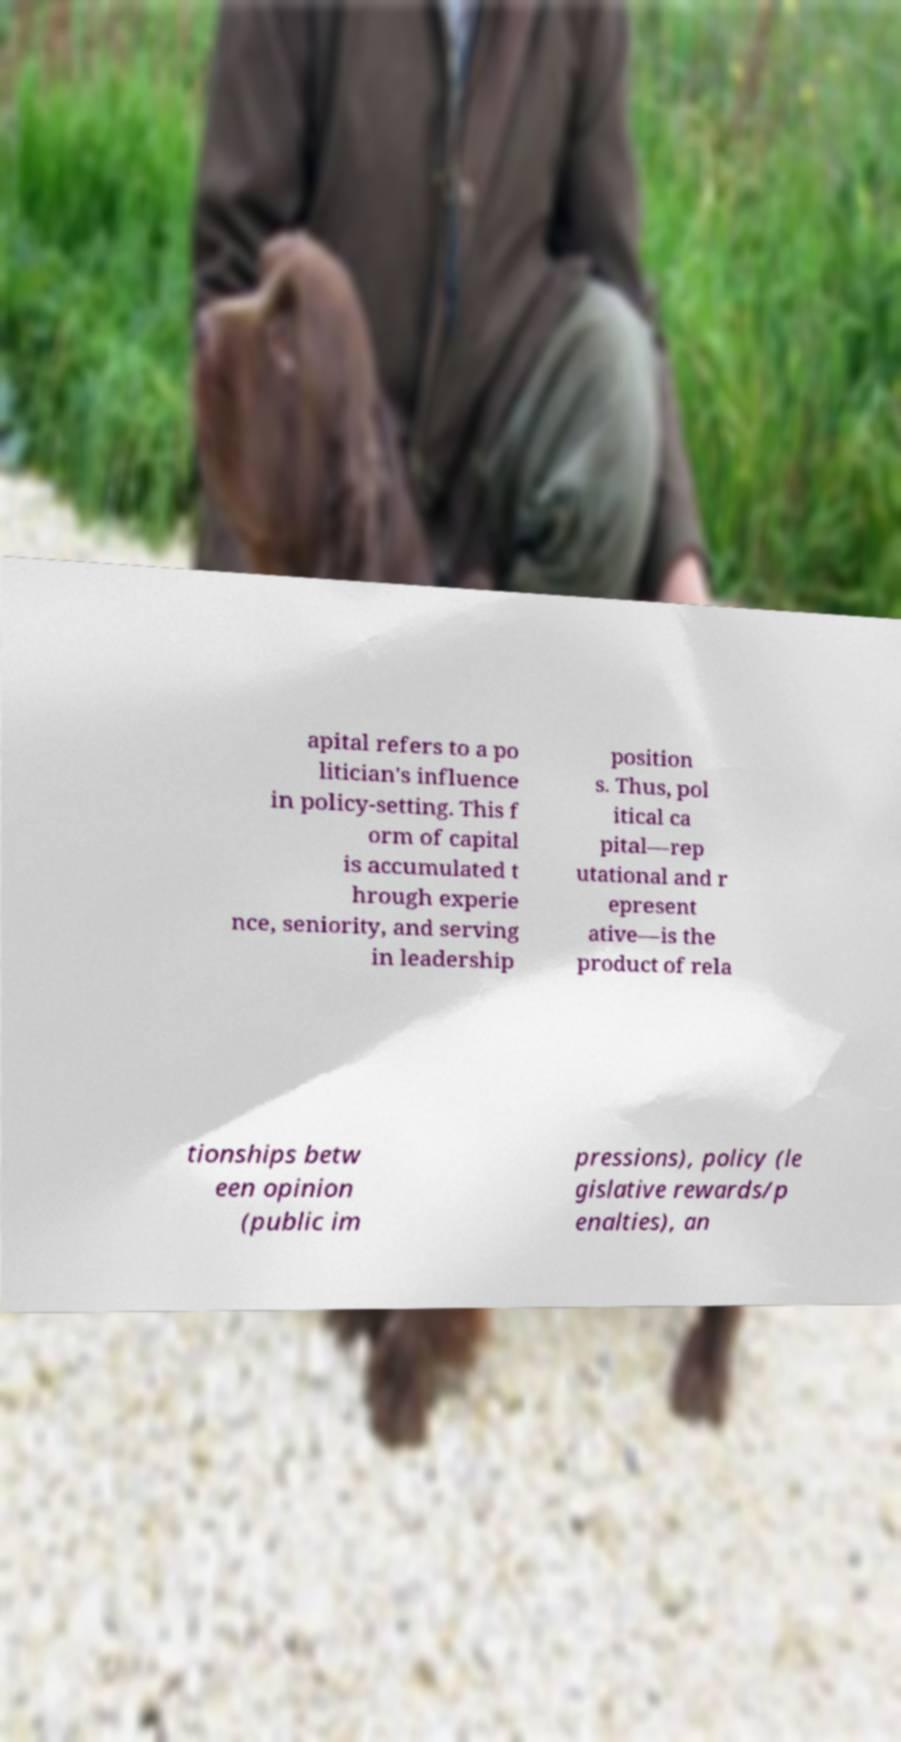Could you assist in decoding the text presented in this image and type it out clearly? apital refers to a po litician's influence in policy-setting. This f orm of capital is accumulated t hrough experie nce, seniority, and serving in leadership position s. Thus, pol itical ca pital—rep utational and r epresent ative—is the product of rela tionships betw een opinion (public im pressions), policy (le gislative rewards/p enalties), an 